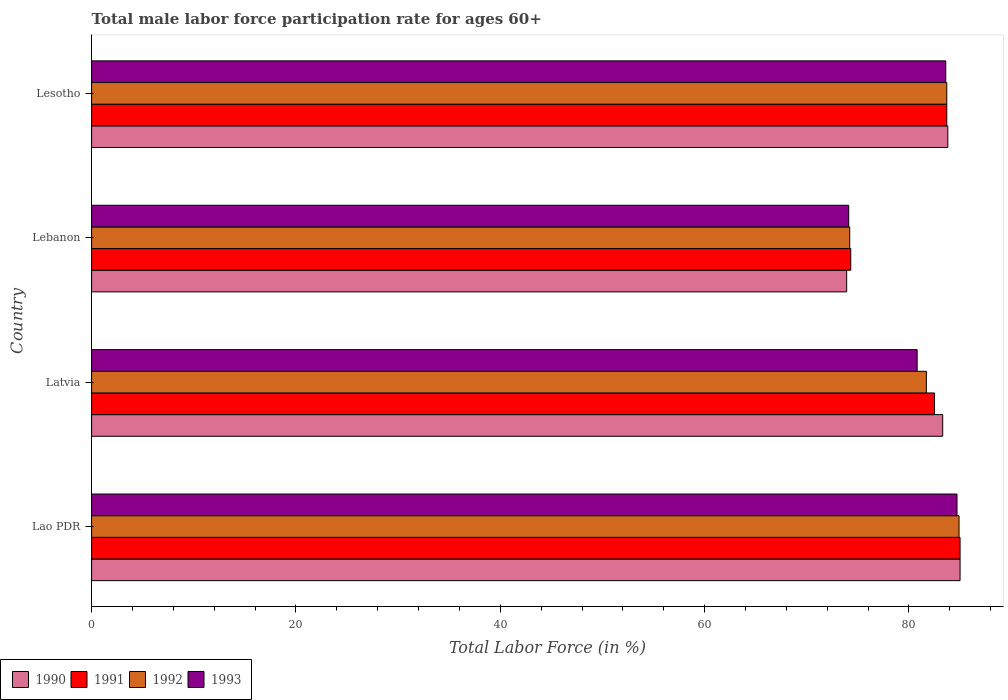How many groups of bars are there?
Make the answer very short. 4. Are the number of bars per tick equal to the number of legend labels?
Offer a terse response. Yes. Are the number of bars on each tick of the Y-axis equal?
Make the answer very short. Yes. How many bars are there on the 4th tick from the bottom?
Offer a terse response. 4. What is the label of the 4th group of bars from the top?
Offer a very short reply. Lao PDR. What is the male labor force participation rate in 1991 in Lebanon?
Provide a short and direct response. 74.3. Across all countries, what is the minimum male labor force participation rate in 1993?
Give a very brief answer. 74.1. In which country was the male labor force participation rate in 1992 maximum?
Provide a short and direct response. Lao PDR. In which country was the male labor force participation rate in 1992 minimum?
Offer a very short reply. Lebanon. What is the total male labor force participation rate in 1993 in the graph?
Provide a succinct answer. 323.2. What is the difference between the male labor force participation rate in 1992 in Latvia and that in Lesotho?
Offer a terse response. -2. What is the difference between the male labor force participation rate in 1992 in Lao PDR and the male labor force participation rate in 1991 in Lebanon?
Give a very brief answer. 10.6. What is the average male labor force participation rate in 1993 per country?
Give a very brief answer. 80.8. What is the difference between the male labor force participation rate in 1993 and male labor force participation rate in 1991 in Latvia?
Give a very brief answer. -1.7. What is the ratio of the male labor force participation rate in 1992 in Latvia to that in Lesotho?
Your response must be concise. 0.98. What is the difference between the highest and the second highest male labor force participation rate in 1991?
Offer a very short reply. 1.3. What is the difference between the highest and the lowest male labor force participation rate in 1992?
Offer a terse response. 10.7. In how many countries, is the male labor force participation rate in 1991 greater than the average male labor force participation rate in 1991 taken over all countries?
Give a very brief answer. 3. Is it the case that in every country, the sum of the male labor force participation rate in 1993 and male labor force participation rate in 1991 is greater than the male labor force participation rate in 1992?
Provide a succinct answer. Yes. How many bars are there?
Provide a succinct answer. 16. What is the difference between two consecutive major ticks on the X-axis?
Provide a short and direct response. 20. Are the values on the major ticks of X-axis written in scientific E-notation?
Your answer should be compact. No. Where does the legend appear in the graph?
Provide a succinct answer. Bottom left. How many legend labels are there?
Ensure brevity in your answer.  4. What is the title of the graph?
Give a very brief answer. Total male labor force participation rate for ages 60+. Does "1974" appear as one of the legend labels in the graph?
Your answer should be very brief. No. What is the label or title of the X-axis?
Provide a succinct answer. Total Labor Force (in %). What is the Total Labor Force (in %) of 1990 in Lao PDR?
Keep it short and to the point. 85. What is the Total Labor Force (in %) of 1992 in Lao PDR?
Your answer should be compact. 84.9. What is the Total Labor Force (in %) in 1993 in Lao PDR?
Make the answer very short. 84.7. What is the Total Labor Force (in %) of 1990 in Latvia?
Provide a short and direct response. 83.3. What is the Total Labor Force (in %) in 1991 in Latvia?
Keep it short and to the point. 82.5. What is the Total Labor Force (in %) of 1992 in Latvia?
Offer a terse response. 81.7. What is the Total Labor Force (in %) in 1993 in Latvia?
Provide a succinct answer. 80.8. What is the Total Labor Force (in %) of 1990 in Lebanon?
Keep it short and to the point. 73.9. What is the Total Labor Force (in %) of 1991 in Lebanon?
Provide a succinct answer. 74.3. What is the Total Labor Force (in %) in 1992 in Lebanon?
Give a very brief answer. 74.2. What is the Total Labor Force (in %) in 1993 in Lebanon?
Keep it short and to the point. 74.1. What is the Total Labor Force (in %) of 1990 in Lesotho?
Provide a short and direct response. 83.8. What is the Total Labor Force (in %) of 1991 in Lesotho?
Give a very brief answer. 83.7. What is the Total Labor Force (in %) in 1992 in Lesotho?
Offer a very short reply. 83.7. What is the Total Labor Force (in %) of 1993 in Lesotho?
Your answer should be very brief. 83.6. Across all countries, what is the maximum Total Labor Force (in %) of 1990?
Ensure brevity in your answer.  85. Across all countries, what is the maximum Total Labor Force (in %) in 1991?
Offer a terse response. 85. Across all countries, what is the maximum Total Labor Force (in %) of 1992?
Keep it short and to the point. 84.9. Across all countries, what is the maximum Total Labor Force (in %) in 1993?
Give a very brief answer. 84.7. Across all countries, what is the minimum Total Labor Force (in %) in 1990?
Provide a short and direct response. 73.9. Across all countries, what is the minimum Total Labor Force (in %) in 1991?
Provide a succinct answer. 74.3. Across all countries, what is the minimum Total Labor Force (in %) of 1992?
Make the answer very short. 74.2. Across all countries, what is the minimum Total Labor Force (in %) in 1993?
Ensure brevity in your answer.  74.1. What is the total Total Labor Force (in %) of 1990 in the graph?
Your response must be concise. 326. What is the total Total Labor Force (in %) in 1991 in the graph?
Ensure brevity in your answer.  325.5. What is the total Total Labor Force (in %) in 1992 in the graph?
Make the answer very short. 324.5. What is the total Total Labor Force (in %) in 1993 in the graph?
Ensure brevity in your answer.  323.2. What is the difference between the Total Labor Force (in %) of 1990 in Lao PDR and that in Latvia?
Keep it short and to the point. 1.7. What is the difference between the Total Labor Force (in %) of 1991 in Lao PDR and that in Latvia?
Give a very brief answer. 2.5. What is the difference between the Total Labor Force (in %) of 1993 in Lao PDR and that in Latvia?
Your answer should be compact. 3.9. What is the difference between the Total Labor Force (in %) in 1990 in Lao PDR and that in Lebanon?
Keep it short and to the point. 11.1. What is the difference between the Total Labor Force (in %) in 1991 in Lao PDR and that in Lebanon?
Your answer should be compact. 10.7. What is the difference between the Total Labor Force (in %) of 1992 in Lao PDR and that in Lebanon?
Provide a succinct answer. 10.7. What is the difference between the Total Labor Force (in %) in 1990 in Lao PDR and that in Lesotho?
Give a very brief answer. 1.2. What is the difference between the Total Labor Force (in %) of 1991 in Lao PDR and that in Lesotho?
Your answer should be compact. 1.3. What is the difference between the Total Labor Force (in %) in 1990 in Latvia and that in Lebanon?
Provide a succinct answer. 9.4. What is the difference between the Total Labor Force (in %) of 1992 in Latvia and that in Lebanon?
Offer a very short reply. 7.5. What is the difference between the Total Labor Force (in %) in 1990 in Latvia and that in Lesotho?
Your answer should be very brief. -0.5. What is the difference between the Total Labor Force (in %) of 1992 in Latvia and that in Lesotho?
Ensure brevity in your answer.  -2. What is the difference between the Total Labor Force (in %) of 1991 in Lebanon and that in Lesotho?
Offer a terse response. -9.4. What is the difference between the Total Labor Force (in %) of 1990 in Lao PDR and the Total Labor Force (in %) of 1992 in Latvia?
Keep it short and to the point. 3.3. What is the difference between the Total Labor Force (in %) in 1991 in Lao PDR and the Total Labor Force (in %) in 1992 in Latvia?
Your answer should be compact. 3.3. What is the difference between the Total Labor Force (in %) in 1992 in Lao PDR and the Total Labor Force (in %) in 1993 in Lebanon?
Offer a very short reply. 10.8. What is the difference between the Total Labor Force (in %) in 1990 in Lao PDR and the Total Labor Force (in %) in 1993 in Lesotho?
Your answer should be compact. 1.4. What is the difference between the Total Labor Force (in %) of 1991 in Lao PDR and the Total Labor Force (in %) of 1992 in Lesotho?
Offer a very short reply. 1.3. What is the difference between the Total Labor Force (in %) in 1990 in Latvia and the Total Labor Force (in %) in 1993 in Lebanon?
Offer a very short reply. 9.2. What is the difference between the Total Labor Force (in %) of 1991 in Latvia and the Total Labor Force (in %) of 1992 in Lebanon?
Your answer should be compact. 8.3. What is the difference between the Total Labor Force (in %) of 1992 in Latvia and the Total Labor Force (in %) of 1993 in Lebanon?
Provide a succinct answer. 7.6. What is the difference between the Total Labor Force (in %) of 1990 in Latvia and the Total Labor Force (in %) of 1991 in Lesotho?
Your answer should be very brief. -0.4. What is the difference between the Total Labor Force (in %) of 1990 in Latvia and the Total Labor Force (in %) of 1992 in Lesotho?
Ensure brevity in your answer.  -0.4. What is the difference between the Total Labor Force (in %) in 1991 in Latvia and the Total Labor Force (in %) in 1992 in Lesotho?
Make the answer very short. -1.2. What is the difference between the Total Labor Force (in %) of 1991 in Latvia and the Total Labor Force (in %) of 1993 in Lesotho?
Ensure brevity in your answer.  -1.1. What is the difference between the Total Labor Force (in %) of 1992 in Lebanon and the Total Labor Force (in %) of 1993 in Lesotho?
Provide a succinct answer. -9.4. What is the average Total Labor Force (in %) of 1990 per country?
Provide a succinct answer. 81.5. What is the average Total Labor Force (in %) in 1991 per country?
Keep it short and to the point. 81.38. What is the average Total Labor Force (in %) in 1992 per country?
Offer a terse response. 81.12. What is the average Total Labor Force (in %) in 1993 per country?
Offer a terse response. 80.8. What is the difference between the Total Labor Force (in %) of 1990 and Total Labor Force (in %) of 1992 in Lao PDR?
Your response must be concise. 0.1. What is the difference between the Total Labor Force (in %) of 1990 and Total Labor Force (in %) of 1991 in Latvia?
Keep it short and to the point. 0.8. What is the difference between the Total Labor Force (in %) in 1990 and Total Labor Force (in %) in 1992 in Latvia?
Ensure brevity in your answer.  1.6. What is the difference between the Total Labor Force (in %) of 1991 and Total Labor Force (in %) of 1992 in Latvia?
Keep it short and to the point. 0.8. What is the difference between the Total Labor Force (in %) of 1992 and Total Labor Force (in %) of 1993 in Latvia?
Keep it short and to the point. 0.9. What is the difference between the Total Labor Force (in %) of 1990 and Total Labor Force (in %) of 1991 in Lebanon?
Ensure brevity in your answer.  -0.4. What is the difference between the Total Labor Force (in %) of 1990 and Total Labor Force (in %) of 1993 in Lebanon?
Provide a short and direct response. -0.2. What is the difference between the Total Labor Force (in %) in 1992 and Total Labor Force (in %) in 1993 in Lebanon?
Keep it short and to the point. 0.1. What is the difference between the Total Labor Force (in %) in 1990 and Total Labor Force (in %) in 1991 in Lesotho?
Offer a very short reply. 0.1. What is the difference between the Total Labor Force (in %) in 1990 and Total Labor Force (in %) in 1992 in Lesotho?
Provide a short and direct response. 0.1. What is the difference between the Total Labor Force (in %) of 1991 and Total Labor Force (in %) of 1992 in Lesotho?
Give a very brief answer. 0. What is the difference between the Total Labor Force (in %) in 1991 and Total Labor Force (in %) in 1993 in Lesotho?
Your response must be concise. 0.1. What is the difference between the Total Labor Force (in %) in 1992 and Total Labor Force (in %) in 1993 in Lesotho?
Offer a very short reply. 0.1. What is the ratio of the Total Labor Force (in %) of 1990 in Lao PDR to that in Latvia?
Your answer should be very brief. 1.02. What is the ratio of the Total Labor Force (in %) in 1991 in Lao PDR to that in Latvia?
Ensure brevity in your answer.  1.03. What is the ratio of the Total Labor Force (in %) in 1992 in Lao PDR to that in Latvia?
Give a very brief answer. 1.04. What is the ratio of the Total Labor Force (in %) in 1993 in Lao PDR to that in Latvia?
Make the answer very short. 1.05. What is the ratio of the Total Labor Force (in %) in 1990 in Lao PDR to that in Lebanon?
Your answer should be compact. 1.15. What is the ratio of the Total Labor Force (in %) of 1991 in Lao PDR to that in Lebanon?
Offer a terse response. 1.14. What is the ratio of the Total Labor Force (in %) of 1992 in Lao PDR to that in Lebanon?
Ensure brevity in your answer.  1.14. What is the ratio of the Total Labor Force (in %) of 1993 in Lao PDR to that in Lebanon?
Keep it short and to the point. 1.14. What is the ratio of the Total Labor Force (in %) of 1990 in Lao PDR to that in Lesotho?
Provide a short and direct response. 1.01. What is the ratio of the Total Labor Force (in %) in 1991 in Lao PDR to that in Lesotho?
Give a very brief answer. 1.02. What is the ratio of the Total Labor Force (in %) of 1992 in Lao PDR to that in Lesotho?
Make the answer very short. 1.01. What is the ratio of the Total Labor Force (in %) of 1993 in Lao PDR to that in Lesotho?
Offer a terse response. 1.01. What is the ratio of the Total Labor Force (in %) of 1990 in Latvia to that in Lebanon?
Offer a terse response. 1.13. What is the ratio of the Total Labor Force (in %) of 1991 in Latvia to that in Lebanon?
Your answer should be very brief. 1.11. What is the ratio of the Total Labor Force (in %) of 1992 in Latvia to that in Lebanon?
Your response must be concise. 1.1. What is the ratio of the Total Labor Force (in %) in 1993 in Latvia to that in Lebanon?
Keep it short and to the point. 1.09. What is the ratio of the Total Labor Force (in %) of 1991 in Latvia to that in Lesotho?
Give a very brief answer. 0.99. What is the ratio of the Total Labor Force (in %) of 1992 in Latvia to that in Lesotho?
Provide a succinct answer. 0.98. What is the ratio of the Total Labor Force (in %) in 1993 in Latvia to that in Lesotho?
Offer a very short reply. 0.97. What is the ratio of the Total Labor Force (in %) of 1990 in Lebanon to that in Lesotho?
Your response must be concise. 0.88. What is the ratio of the Total Labor Force (in %) of 1991 in Lebanon to that in Lesotho?
Make the answer very short. 0.89. What is the ratio of the Total Labor Force (in %) in 1992 in Lebanon to that in Lesotho?
Provide a short and direct response. 0.89. What is the ratio of the Total Labor Force (in %) of 1993 in Lebanon to that in Lesotho?
Offer a terse response. 0.89. What is the difference between the highest and the second highest Total Labor Force (in %) of 1990?
Keep it short and to the point. 1.2. What is the difference between the highest and the second highest Total Labor Force (in %) of 1991?
Your response must be concise. 1.3. What is the difference between the highest and the second highest Total Labor Force (in %) in 1993?
Your answer should be compact. 1.1. What is the difference between the highest and the lowest Total Labor Force (in %) of 1991?
Provide a succinct answer. 10.7. What is the difference between the highest and the lowest Total Labor Force (in %) of 1992?
Provide a succinct answer. 10.7. 